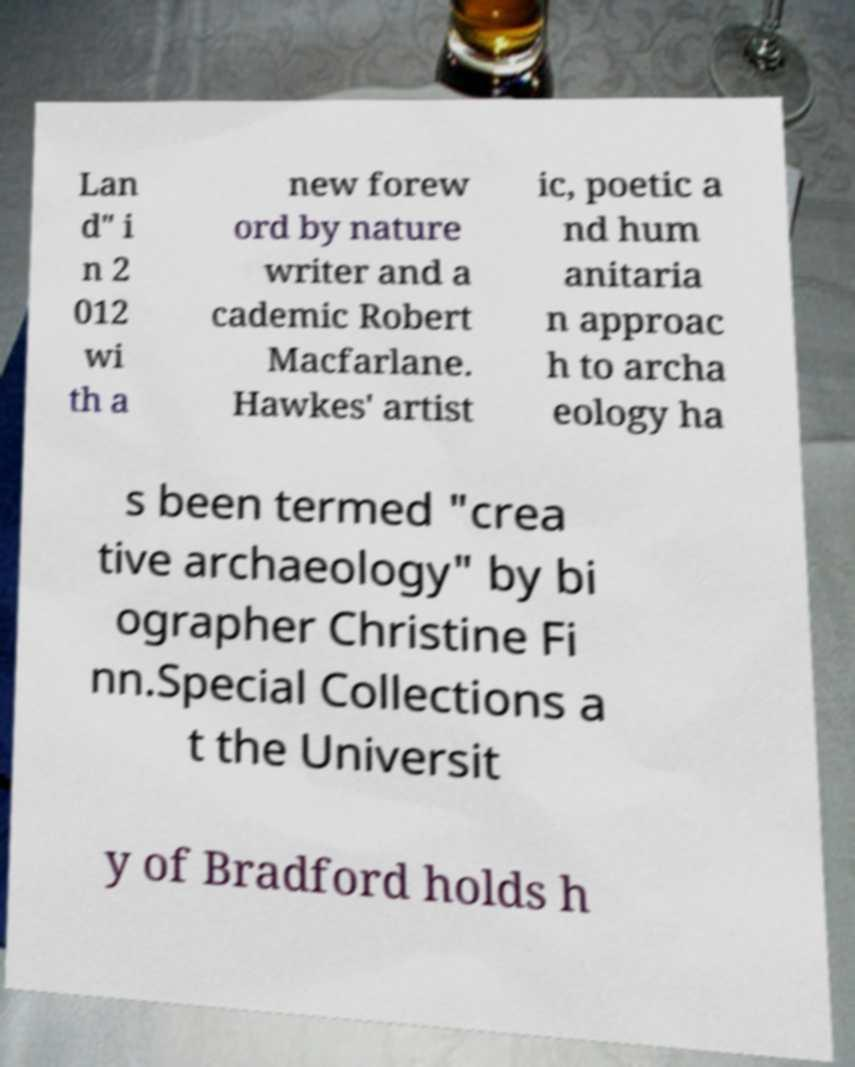Please read and relay the text visible in this image. What does it say? Lan d" i n 2 012 wi th a new forew ord by nature writer and a cademic Robert Macfarlane. Hawkes' artist ic, poetic a nd hum anitaria n approac h to archa eology ha s been termed "crea tive archaeology" by bi ographer Christine Fi nn.Special Collections a t the Universit y of Bradford holds h 